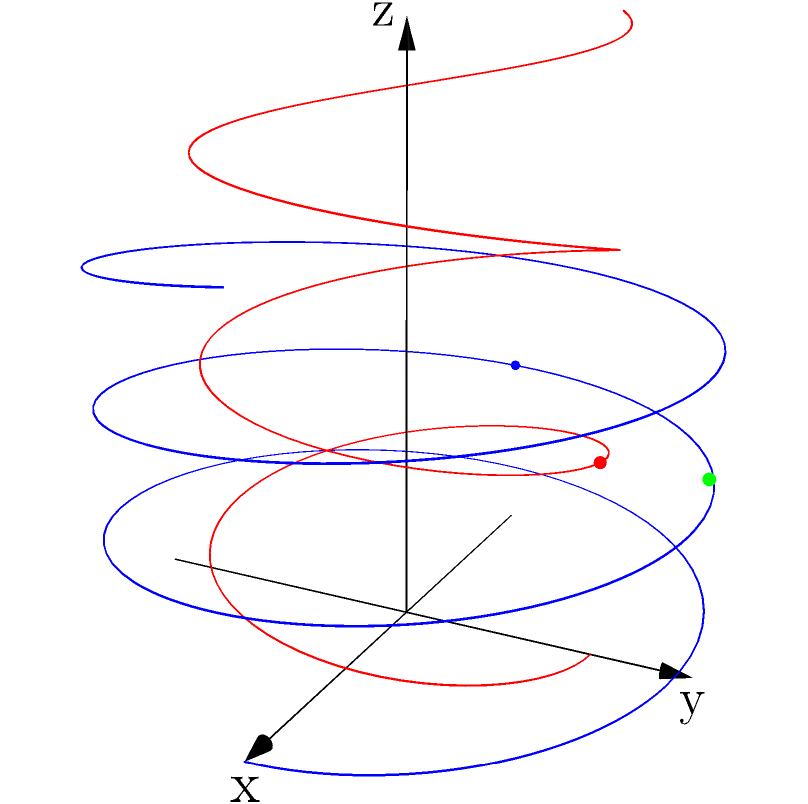Two satellites are orbiting Earth in different trajectories. Satellite A follows the path described by the parametric equations $x = 3\cos(t)$, $y = 3\sin(t)$, $z = t/3$, while Satellite B follows $x = 2\sin(t)$, $y = 2\cos(t)$, $z = t/2$, where $t$ is the time parameter. At what point in 3D space do these satellites' orbits intersect? Express your answer as a coordinate point $(x, y, z)$. To find the intersection point, we need to equate the parametric equations for both satellites:

1) For x-coordinate: $3\cos(t_1) = 2\sin(t_2)$
2) For y-coordinate: $3\sin(t_1) = 2\cos(t_2)$
3) For z-coordinate: $t_1/3 = t_2/2$

From (3), we can deduce that $t_1 = 3\pi$ and $t_2 = 2\pi$ at the intersection point.

Substituting $t_1 = 3\pi$ into Satellite A's equations:
x = $3\cos(3\pi) = -3$
y = $3\sin(3\pi) = 0$
z = $3\pi/3 = \pi$

Verifying with Satellite B's equations using $t_2 = 2\pi$:
x = $2\sin(2\pi) = 0$
y = $2\cos(2\pi) = 2$
z = $2\pi/2 = \pi$

The y-coordinates don't match, so we need to find another solution.

Observing the equations, we can see that when $x = 0$, $y = 3$, and $z = \pi$, both sets of equations are satisfied:

For Satellite A: $t_1 = \pi/2$
$3\cos(\pi/2) = 0$
$3\sin(\pi/2) = 3$
$(\pi/2)/3 = \pi/6$

For Satellite B: $t_2 = 2\pi$
$2\sin(2\pi) = 0$
$2\cos(2\pi) = 2$
$(2\pi)/2 = \pi$

Therefore, the intersection point is $(0, 3, \pi)$.
Answer: $(0, 3, \pi)$ 